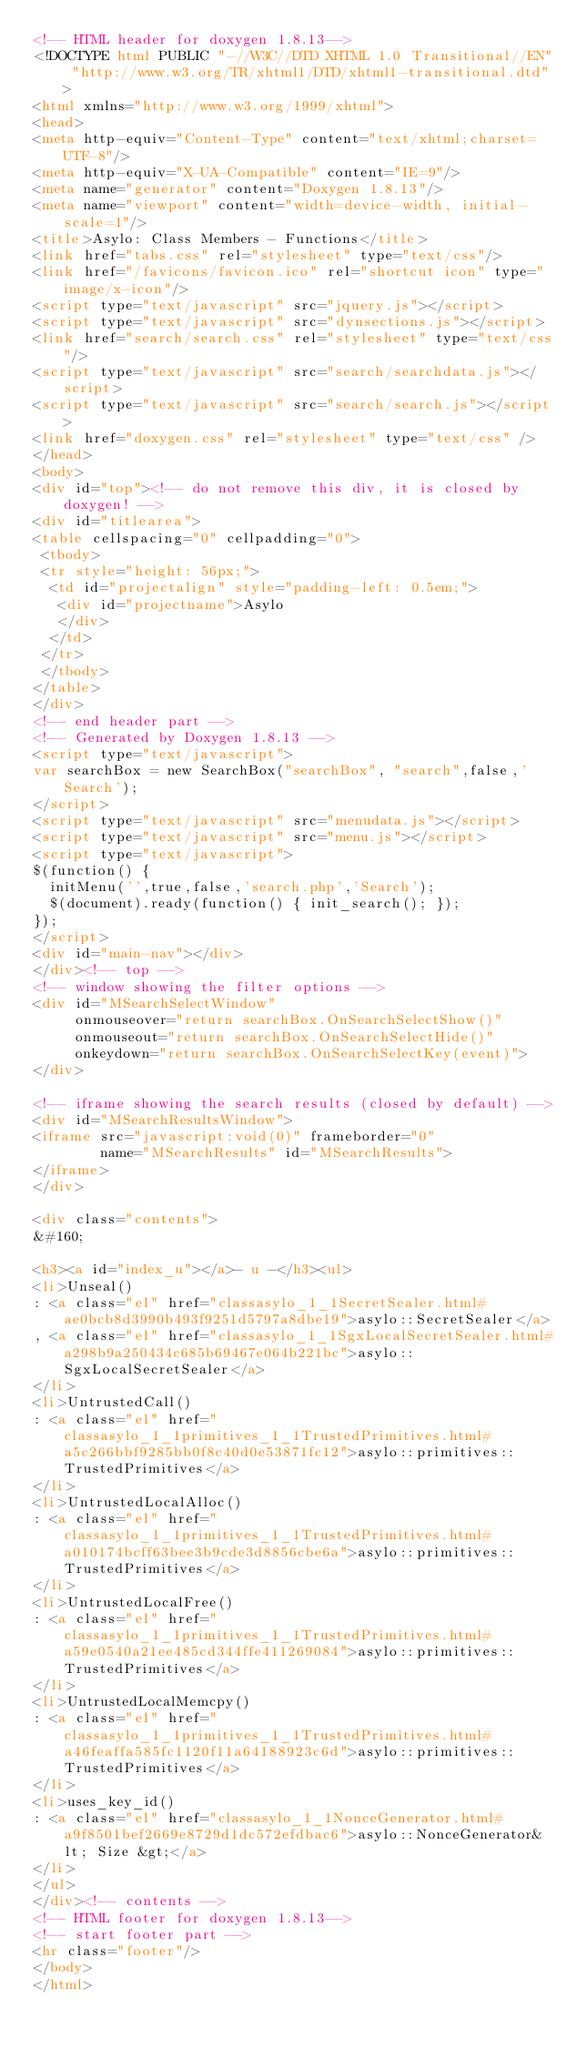<code> <loc_0><loc_0><loc_500><loc_500><_HTML_><!-- HTML header for doxygen 1.8.13-->
<!DOCTYPE html PUBLIC "-//W3C//DTD XHTML 1.0 Transitional//EN" "http://www.w3.org/TR/xhtml1/DTD/xhtml1-transitional.dtd">
<html xmlns="http://www.w3.org/1999/xhtml">
<head>
<meta http-equiv="Content-Type" content="text/xhtml;charset=UTF-8"/>
<meta http-equiv="X-UA-Compatible" content="IE=9"/>
<meta name="generator" content="Doxygen 1.8.13"/>
<meta name="viewport" content="width=device-width, initial-scale=1"/>
<title>Asylo: Class Members - Functions</title>
<link href="tabs.css" rel="stylesheet" type="text/css"/>
<link href="/favicons/favicon.ico" rel="shortcut icon" type="image/x-icon"/>
<script type="text/javascript" src="jquery.js"></script>
<script type="text/javascript" src="dynsections.js"></script>
<link href="search/search.css" rel="stylesheet" type="text/css"/>
<script type="text/javascript" src="search/searchdata.js"></script>
<script type="text/javascript" src="search/search.js"></script>
<link href="doxygen.css" rel="stylesheet" type="text/css" />
</head>
<body>
<div id="top"><!-- do not remove this div, it is closed by doxygen! -->
<div id="titlearea">
<table cellspacing="0" cellpadding="0">
 <tbody>
 <tr style="height: 56px;">
  <td id="projectalign" style="padding-left: 0.5em;">
   <div id="projectname">Asylo
   </div>
  </td>
 </tr>
 </tbody>
</table>
</div>
<!-- end header part -->
<!-- Generated by Doxygen 1.8.13 -->
<script type="text/javascript">
var searchBox = new SearchBox("searchBox", "search",false,'Search');
</script>
<script type="text/javascript" src="menudata.js"></script>
<script type="text/javascript" src="menu.js"></script>
<script type="text/javascript">
$(function() {
  initMenu('',true,false,'search.php','Search');
  $(document).ready(function() { init_search(); });
});
</script>
<div id="main-nav"></div>
</div><!-- top -->
<!-- window showing the filter options -->
<div id="MSearchSelectWindow"
     onmouseover="return searchBox.OnSearchSelectShow()"
     onmouseout="return searchBox.OnSearchSelectHide()"
     onkeydown="return searchBox.OnSearchSelectKey(event)">
</div>

<!-- iframe showing the search results (closed by default) -->
<div id="MSearchResultsWindow">
<iframe src="javascript:void(0)" frameborder="0" 
        name="MSearchResults" id="MSearchResults">
</iframe>
</div>

<div class="contents">
&#160;

<h3><a id="index_u"></a>- u -</h3><ul>
<li>Unseal()
: <a class="el" href="classasylo_1_1SecretSealer.html#ae0bcb8d3990b493f9251d5797a8dbe19">asylo::SecretSealer</a>
, <a class="el" href="classasylo_1_1SgxLocalSecretSealer.html#a298b9a250434c685b69467e064b221bc">asylo::SgxLocalSecretSealer</a>
</li>
<li>UntrustedCall()
: <a class="el" href="classasylo_1_1primitives_1_1TrustedPrimitives.html#a5c266bbf9285bb0f8c40d0e53871fc12">asylo::primitives::TrustedPrimitives</a>
</li>
<li>UntrustedLocalAlloc()
: <a class="el" href="classasylo_1_1primitives_1_1TrustedPrimitives.html#a010174bcff63bee3b9cde3d8856cbe6a">asylo::primitives::TrustedPrimitives</a>
</li>
<li>UntrustedLocalFree()
: <a class="el" href="classasylo_1_1primitives_1_1TrustedPrimitives.html#a59e0540a21ee485cd344ffe411269084">asylo::primitives::TrustedPrimitives</a>
</li>
<li>UntrustedLocalMemcpy()
: <a class="el" href="classasylo_1_1primitives_1_1TrustedPrimitives.html#a46feaffa585fc1120f11a64188923c6d">asylo::primitives::TrustedPrimitives</a>
</li>
<li>uses_key_id()
: <a class="el" href="classasylo_1_1NonceGenerator.html#a9f8501bef2669e8729d1dc572efdbac6">asylo::NonceGenerator&lt; Size &gt;</a>
</li>
</ul>
</div><!-- contents -->
<!-- HTML footer for doxygen 1.8.13-->
<!-- start footer part -->
<hr class="footer"/>
</body>
</html>
</code> 